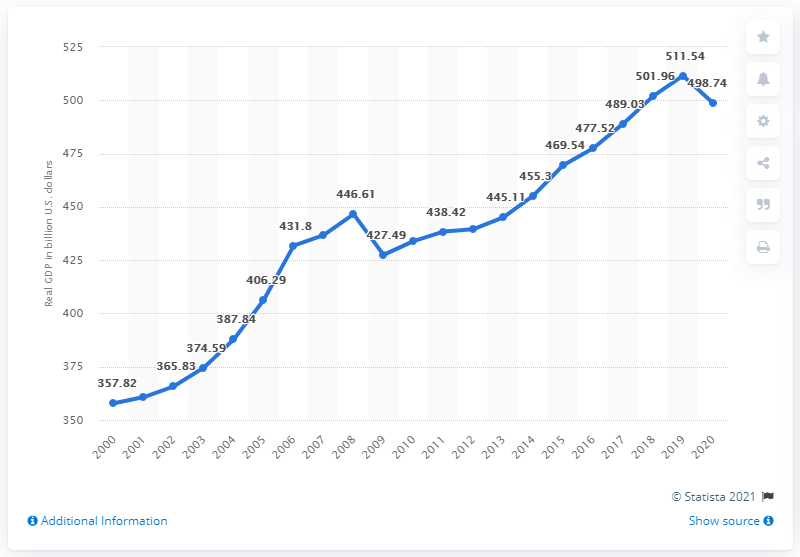Outline some significant characteristics in this image. In the prior year, North Carolina's Gross Domestic Product (GDP) was $511.54 billion. In 2020, North Carolina's Gross Domestic Product (GDP) was 498.74. 